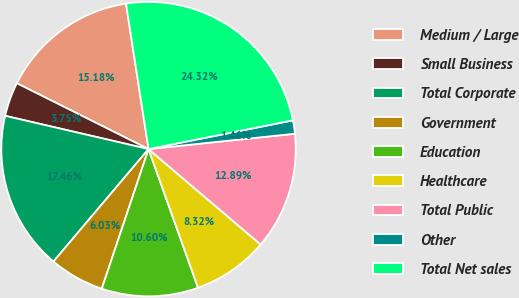Convert chart. <chart><loc_0><loc_0><loc_500><loc_500><pie_chart><fcel>Medium / Large<fcel>Small Business<fcel>Total Corporate<fcel>Government<fcel>Education<fcel>Healthcare<fcel>Total Public<fcel>Other<fcel>Total Net sales<nl><fcel>15.18%<fcel>3.75%<fcel>17.46%<fcel>6.03%<fcel>10.6%<fcel>8.32%<fcel>12.89%<fcel>1.46%<fcel>24.32%<nl></chart> 